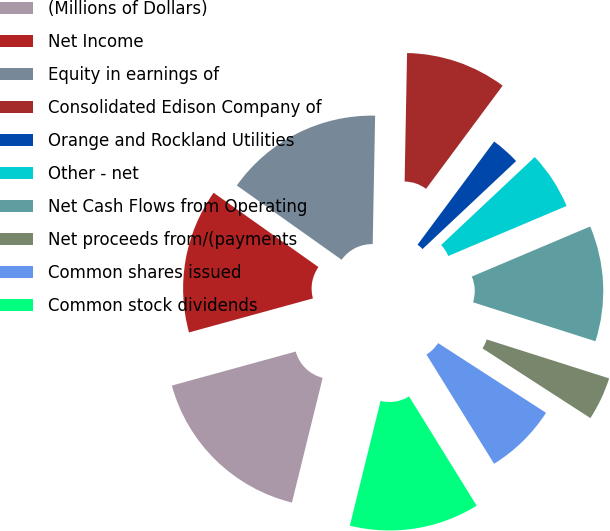Convert chart to OTSL. <chart><loc_0><loc_0><loc_500><loc_500><pie_chart><fcel>(Millions of Dollars)<fcel>Net Income<fcel>Equity in earnings of<fcel>Consolidated Edison Company of<fcel>Orange and Rockland Utilities<fcel>Other - net<fcel>Net Cash Flows from Operating<fcel>Net proceeds from/(payments<fcel>Common shares issued<fcel>Common stock dividends<nl><fcel>16.89%<fcel>14.08%<fcel>15.49%<fcel>9.86%<fcel>2.83%<fcel>5.64%<fcel>11.27%<fcel>4.23%<fcel>7.05%<fcel>12.67%<nl></chart> 